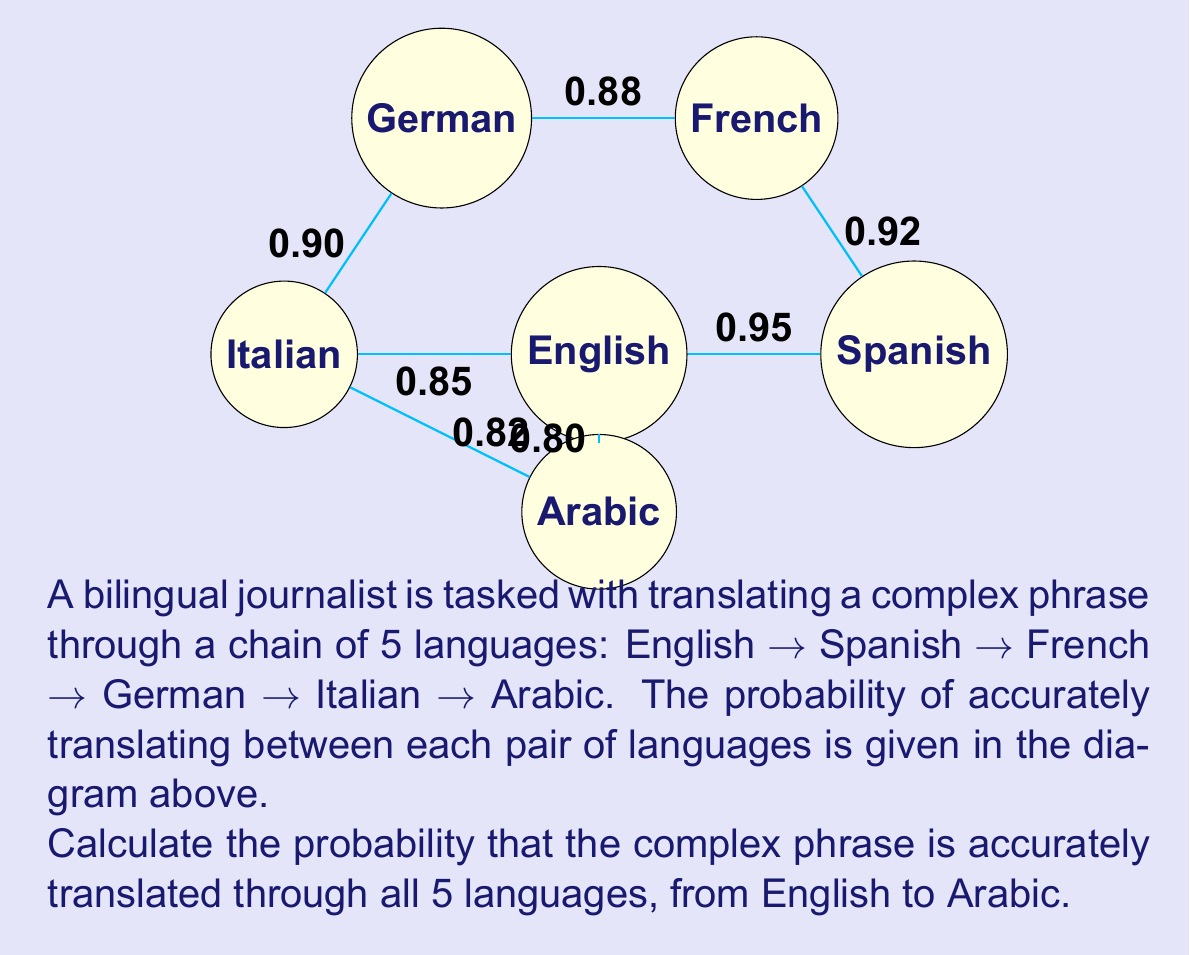Can you solve this math problem? To solve this problem, we need to follow these steps:

1) In a chain of translations, the overall accuracy depends on the successful translation at each step. This is analogous to the probability of independent events occurring in sequence.

2) For independent events, we multiply the individual probabilities to get the probability of all events occurring.

3) Let's identify the probabilities for each translation step:
   English → Spanish: 0.95
   Spanish → French: 0.92
   French → German: 0.88
   German → Italian: 0.90
   Italian → Arabic: 0.82

4) Now, we multiply these probabilities:

   $$P(\text{accurate translation}) = 0.95 \times 0.92 \times 0.88 \times 0.90 \times 0.82$$

5) Let's calculate:
   $$P(\text{accurate translation}) = 0.5431968$$

6) This can be rounded to 4 decimal places:
   $$P(\text{accurate translation}) \approx 0.5432$$

Therefore, the probability of accurately translating the complex phrase through all 5 languages is approximately 0.5432 or 54.32%.
Answer: $0.5432$ or $54.32\%$ 